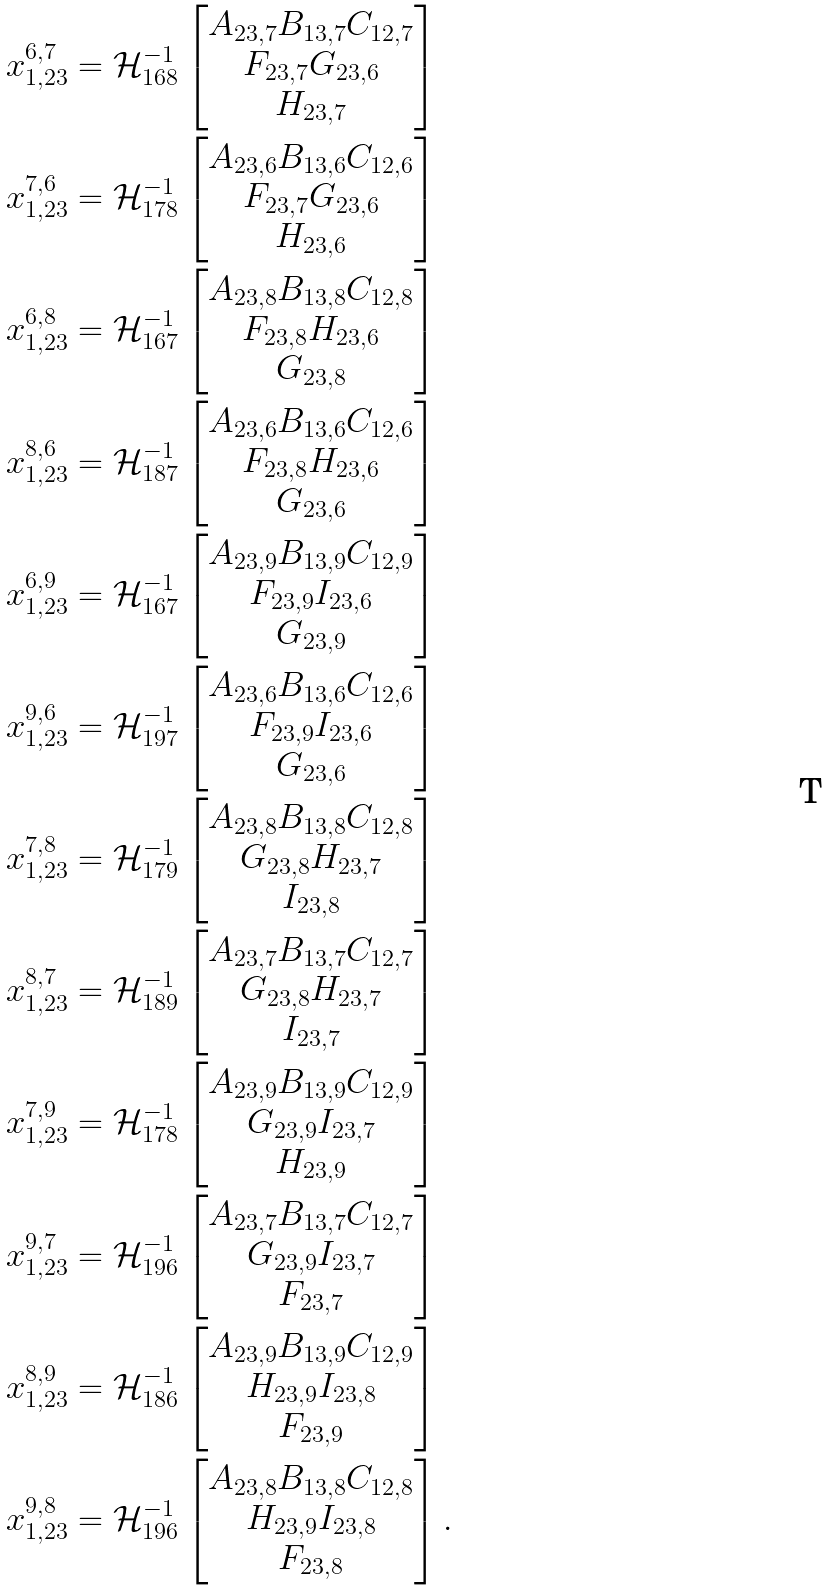<formula> <loc_0><loc_0><loc_500><loc_500>x _ { 1 , 2 3 } ^ { 6 , 7 } & = \mathcal { H } ^ { - 1 } _ { 1 6 8 } \begin{bmatrix} A _ { 2 3 , 7 } B _ { 1 3 , 7 } C _ { 1 2 , 7 } \\ F _ { 2 3 , 7 } G _ { 2 3 , 6 } \\ H _ { 2 3 , 7 } \end{bmatrix} \\ x _ { 1 , 2 3 } ^ { 7 , 6 } & = \mathcal { H } ^ { - 1 } _ { 1 7 8 } \begin{bmatrix} A _ { 2 3 , 6 } B _ { 1 3 , 6 } C _ { 1 2 , 6 } \\ F _ { 2 3 , 7 } G _ { 2 3 , 6 } \\ H _ { 2 3 , 6 } \end{bmatrix} \\ x _ { 1 , 2 3 } ^ { 6 , 8 } & = \mathcal { H } ^ { - 1 } _ { 1 6 7 } \begin{bmatrix} A _ { 2 3 , 8 } B _ { 1 3 , 8 } C _ { 1 2 , 8 } \\ F _ { 2 3 , 8 } H _ { 2 3 , 6 } \\ G _ { 2 3 , 8 } \end{bmatrix} \\ x _ { 1 , 2 3 } ^ { 8 , 6 } & = \mathcal { H } ^ { - 1 } _ { 1 8 7 } \begin{bmatrix} A _ { 2 3 , 6 } B _ { 1 3 , 6 } C _ { 1 2 , 6 } \\ F _ { 2 3 , 8 } H _ { 2 3 , 6 } \\ G _ { 2 3 , 6 } \end{bmatrix} \\ x _ { 1 , 2 3 } ^ { 6 , 9 } & = \mathcal { H } ^ { - 1 } _ { 1 6 7 } \begin{bmatrix} A _ { 2 3 , 9 } B _ { 1 3 , 9 } C _ { 1 2 , 9 } \\ F _ { 2 3 , 9 } I _ { 2 3 , 6 } \\ G _ { 2 3 , 9 } \end{bmatrix} \\ x _ { 1 , 2 3 } ^ { 9 , 6 } & = \mathcal { H } ^ { - 1 } _ { 1 9 7 } \begin{bmatrix} A _ { 2 3 , 6 } B _ { 1 3 , 6 } C _ { 1 2 , 6 } \\ F _ { 2 3 , 9 } I _ { 2 3 , 6 } \\ G _ { 2 3 , 6 } \end{bmatrix} \\ x _ { 1 , 2 3 } ^ { 7 , 8 } & = \mathcal { H } ^ { - 1 } _ { 1 7 9 } \begin{bmatrix} A _ { 2 3 , 8 } B _ { 1 3 , 8 } C _ { 1 2 , 8 } \\ G _ { 2 3 , 8 } H _ { 2 3 , 7 } \\ I _ { 2 3 , 8 } \end{bmatrix} \\ x _ { 1 , 2 3 } ^ { 8 , 7 } & = \mathcal { H } ^ { - 1 } _ { 1 8 9 } \begin{bmatrix} A _ { 2 3 , 7 } B _ { 1 3 , 7 } C _ { 1 2 , 7 } \\ G _ { 2 3 , 8 } H _ { 2 3 , 7 } \\ I _ { 2 3 , 7 } \end{bmatrix} \\ x _ { 1 , 2 3 } ^ { 7 , 9 } & = \mathcal { H } ^ { - 1 } _ { 1 7 8 } \begin{bmatrix} A _ { 2 3 , 9 } B _ { 1 3 , 9 } C _ { 1 2 , 9 } \\ G _ { 2 3 , 9 } I _ { 2 3 , 7 } \\ H _ { 2 3 , 9 } \end{bmatrix} \\ x _ { 1 , 2 3 } ^ { 9 , 7 } & = \mathcal { H } ^ { - 1 } _ { 1 9 6 } \begin{bmatrix} A _ { 2 3 , 7 } B _ { 1 3 , 7 } C _ { 1 2 , 7 } \\ G _ { 2 3 , 9 } I _ { 2 3 , 7 } \\ F _ { 2 3 , 7 } \end{bmatrix} \\ x _ { 1 , 2 3 } ^ { 8 , 9 } & = \mathcal { H } ^ { - 1 } _ { 1 8 6 } \begin{bmatrix} A _ { 2 3 , 9 } B _ { 1 3 , 9 } C _ { 1 2 , 9 } \\ H _ { 2 3 , 9 } I _ { 2 3 , 8 } \\ F _ { 2 3 , 9 } \end{bmatrix} \\ x _ { 1 , 2 3 } ^ { 9 , 8 } & = \mathcal { H } ^ { - 1 } _ { 1 9 6 } \begin{bmatrix} A _ { 2 3 , 8 } B _ { 1 3 , 8 } C _ { 1 2 , 8 } \\ H _ { 2 3 , 9 } I _ { 2 3 , 8 } \\ F _ { 2 3 , 8 } \end{bmatrix} .</formula> 